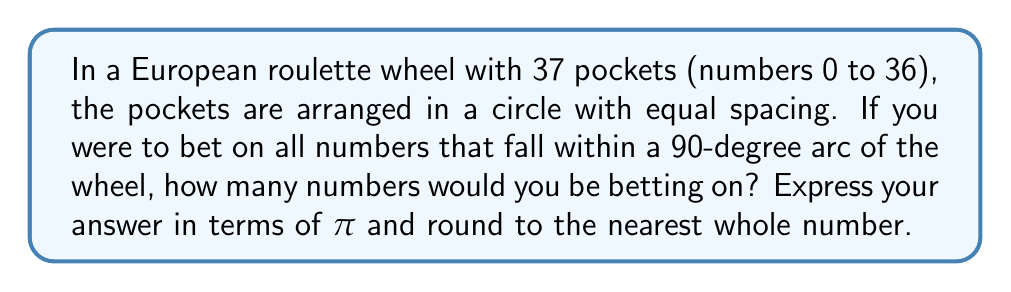Provide a solution to this math problem. Let's approach this step-by-step:

1) First, we need to calculate the angle between each pocket:
   $$\text{Angle per pocket} = \frac{360°}{37} \approx 9.73°$$

2) Now, we need to determine how many of these 9.73° segments fit into a 90° arc:
   $$\text{Number of pockets} = \frac{90°}{9.73°} \approx 9.25$$

3) However, this is not the most precise method. We can use trigonometry for a more accurate result:

4) The central angle $\theta$ for each pocket is:
   $$\theta = \frac{2\pi}{37} \text{ radians}$$

5) For a 90° arc (which is $\frac{\pi}{2}$ radians), the number of pockets $n$ satisfies:
   $$n\theta = \frac{\pi}{2}$$

6) Substituting the value of $\theta$:
   $$n\left(\frac{2\pi}{37}\right) = \frac{\pi}{2}$$

7) Solving for $n$:
   $$n = \frac{37}{4} = 9.25$$

8) Rounding to the nearest whole number:
   $$n \approx 9$$

Therefore, you would be betting on approximately 9 numbers.
Answer: $9$ 